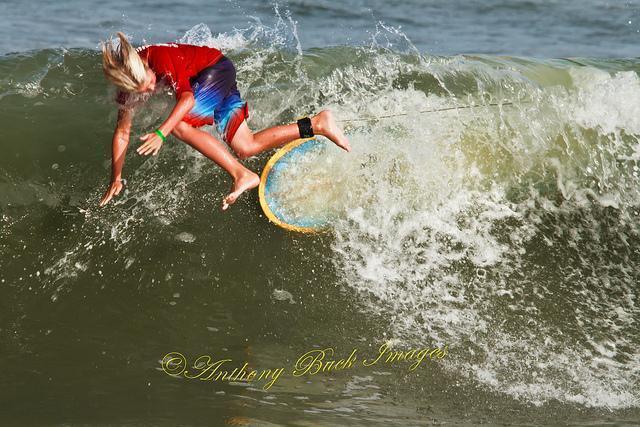How many people are there?
Give a very brief answer. 1. 